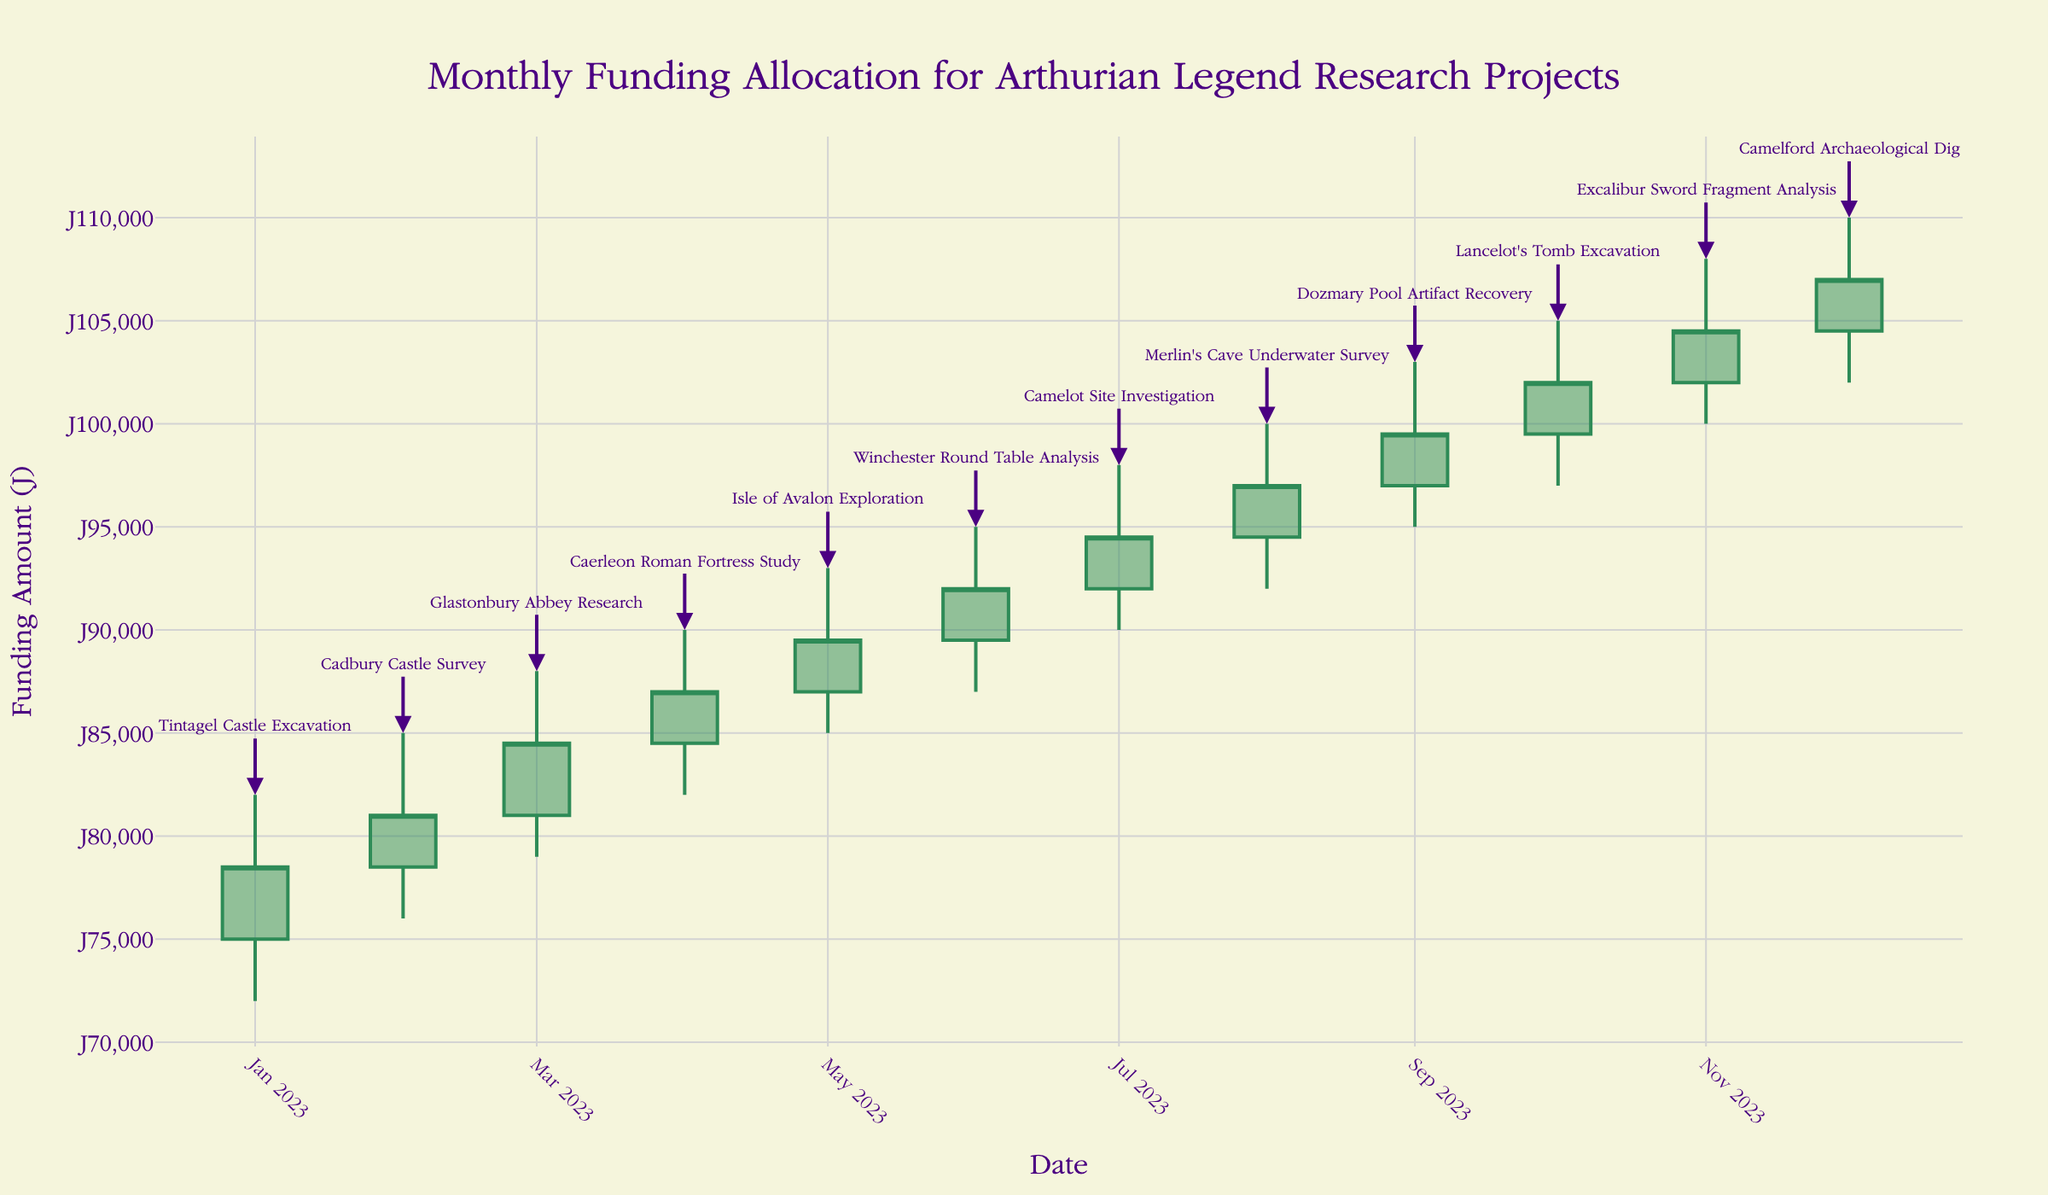what is the title of the chart? The title of the chart is typically found at the top of the figure, in this case, it reads 'Monthly Funding Allocation for Arthurian Legend Research Projects'
Answer: Monthly Funding Allocation for Arthurian Legend Research Projects What is the funding amount for the "Tintagel Castle Excavation" project in January 2023? In January 2023, the funding amount for "Tintagel Castle Excavation" is represented by the "Close" value in that month's candlestick, which is £78,500
Answer: £78,500 Which project had the highest monthly funding allocation by the end of 2023? The highest monthly funding allocation by the end of 2023 can be determined by looking at the highest "Close" value on the chart, which is the "Camelford Archaeological Dig" in December 2023 closing at £107,000
Answer: Camelford Archaeological Dig How did the monthly funding allocation change from January 2023 to December 2023? The change in monthly funding allocation from January 2023 (£78,500) to December 2023 (£107,000) can be calculated by subtracting the January value from the December value. The change is £107,000 - £78,500 = £28,500
Answer: Increased by £28,500 What was the lowest funding allocation observed and for which project and month? The lowest funding allocation is represented by the "Low" values in the data. By examining these, we see that January 2023 had the lowest "Low" value of £72,000 for the project "Tintagel Castle Excavation"
Answer: £72,000 for Tintagel Castle Excavation in January Which month saw the greatest fluctuation in funding allocation and by how much? The month with the greatest fluctuation in funding can be identified by looking at the difference between the "High" and "Low" within a single month. In November 2023, the fluctuation is £108,000 (High) - £100,000 (Low) = £8,000
Answer: November, £8,000 Did any project maintain a perfect increase in monthly funding over its active months? Checking each project's "Close" value, we see the "Dozmary Pool Artifact Recovery" (August to September) and "Camelford Archaeological Dig" (November to December) both show an uninterrupted increase
Answer: Dozmary Pool Artifact Recovery and Camelford Archaeological Dig What project had the consistent highest allocation from May to August? Comparing the "Close" values from May to August, the "Merlin's Cave Underwater Survey" in August 2023 had the highest allocation consistently increasing to £97,000
Answer: Merlin's Cave Underwater Survey Comparing "Glastonbury Abbey Research" in March 2023 and "Excalibur Sword Fragment Analysis" in November 2023, which month had higher funding? By looking at the "Close" values, "Excalibur Sword Fragment Analysis" in November 2023 (£104,500) had higher funding compared to "Glastonbury Abbey Research" in March 2023 (£84,500)
Answer: Excalibur Sword Fragment Analysis How many projects had their highest funding allocation over £100,000? Projects reaching above the £100,000 mark can be determined by looking at the "High" values. These include "Excalibur Sword Fragment Analysis," "Lancelot's Tomb Excavation," and "Camelford Archaeological Dig"
Answer: Three projects 